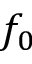<formula> <loc_0><loc_0><loc_500><loc_500>f _ { 0 }</formula> 